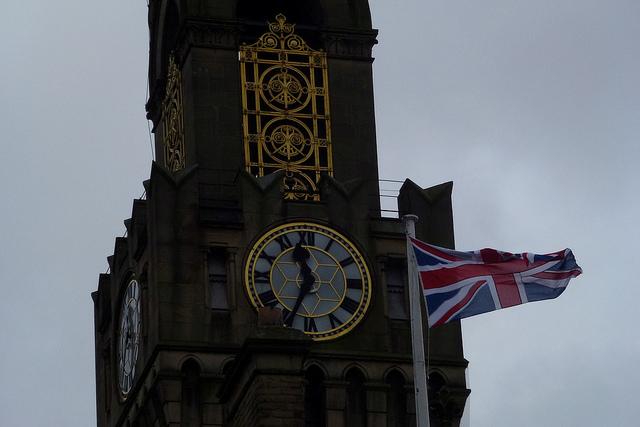What kind of flags are these?
Answer briefly. British. What type of building is the clock on?
Quick response, please. Tower. Does this clock show intricate craftsmanship?
Give a very brief answer. Yes. Is the clock face illuminated in one of the pictures?
Concise answer only. No. Where is the picture taken from?
Give a very brief answer. Ground. What country is this in?
Concise answer only. England. Why is the American flag at the top of the poll?
Be succinct. Patriotism. What time is it?
Answer briefly. 11:34. What color is the statue?
Quick response, please. Brown. What metallic shade are the numbers?
Write a very short answer. Black. What flag can be seen?
Write a very short answer. British. What color is the sky?
Write a very short answer. Gray. This building is in what city?
Be succinct. London. Is the tower weathered?
Quick response, please. No. 